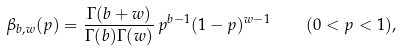Convert formula to latex. <formula><loc_0><loc_0><loc_500><loc_500>\beta _ { b , w } ( p ) = \frac { \Gamma ( b + w ) } { \Gamma ( b ) \Gamma ( w ) } \, p ^ { b - 1 } ( 1 - p ) ^ { w - 1 } \quad ( 0 < p < 1 ) ,</formula> 